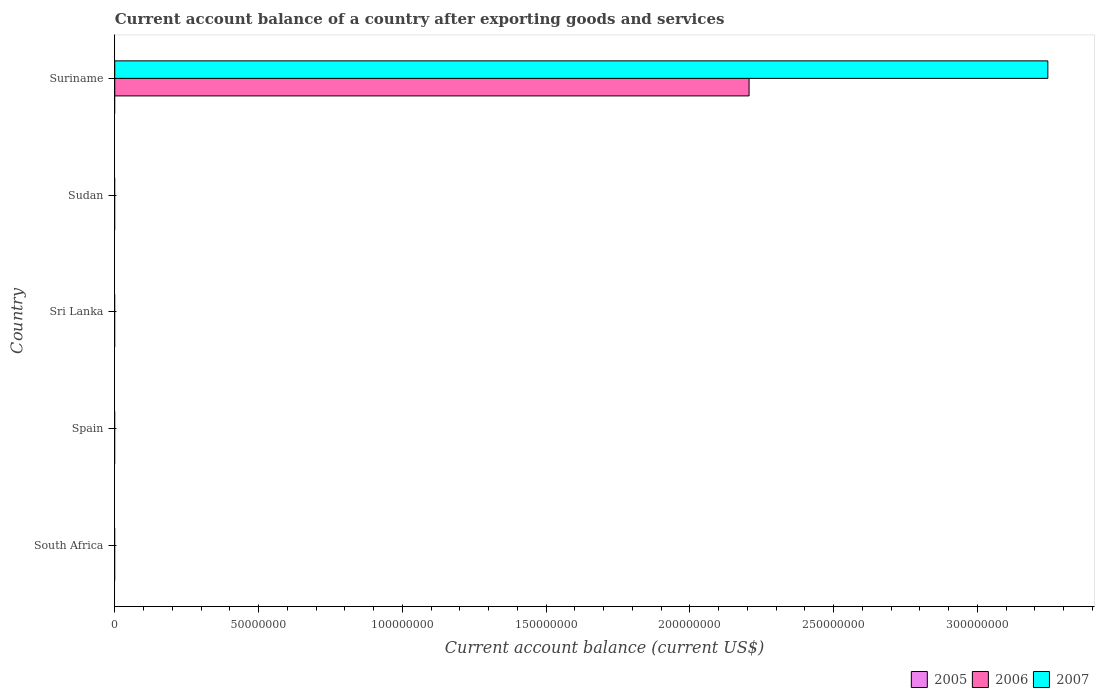How many bars are there on the 2nd tick from the top?
Make the answer very short. 0. What is the label of the 1st group of bars from the top?
Provide a succinct answer. Suriname. Across all countries, what is the maximum account balance in 2007?
Provide a short and direct response. 3.24e+08. In which country was the account balance in 2006 maximum?
Your answer should be very brief. Suriname. What is the total account balance in 2006 in the graph?
Provide a short and direct response. 2.21e+08. What is the difference between the account balance in 2005 in Spain and the account balance in 2006 in Suriname?
Give a very brief answer. -2.21e+08. What is the difference between the account balance in 2006 and account balance in 2007 in Suriname?
Your answer should be very brief. -1.04e+08. In how many countries, is the account balance in 2007 greater than 190000000 US$?
Ensure brevity in your answer.  1. What is the difference between the highest and the lowest account balance in 2006?
Your answer should be compact. 2.21e+08. In how many countries, is the account balance in 2006 greater than the average account balance in 2006 taken over all countries?
Your response must be concise. 1. Is it the case that in every country, the sum of the account balance in 2006 and account balance in 2007 is greater than the account balance in 2005?
Keep it short and to the point. No. Are all the bars in the graph horizontal?
Make the answer very short. Yes. How many countries are there in the graph?
Keep it short and to the point. 5. What is the difference between two consecutive major ticks on the X-axis?
Your answer should be compact. 5.00e+07. Are the values on the major ticks of X-axis written in scientific E-notation?
Your answer should be compact. No. Does the graph contain any zero values?
Make the answer very short. Yes. Where does the legend appear in the graph?
Make the answer very short. Bottom right. How many legend labels are there?
Offer a terse response. 3. What is the title of the graph?
Offer a terse response. Current account balance of a country after exporting goods and services. Does "2001" appear as one of the legend labels in the graph?
Your answer should be very brief. No. What is the label or title of the X-axis?
Provide a short and direct response. Current account balance (current US$). What is the Current account balance (current US$) in 2005 in South Africa?
Keep it short and to the point. 0. What is the Current account balance (current US$) of 2007 in Spain?
Provide a succinct answer. 0. What is the Current account balance (current US$) in 2005 in Sri Lanka?
Make the answer very short. 0. What is the Current account balance (current US$) of 2006 in Sri Lanka?
Provide a short and direct response. 0. What is the Current account balance (current US$) of 2007 in Sri Lanka?
Your answer should be very brief. 0. What is the Current account balance (current US$) of 2005 in Sudan?
Ensure brevity in your answer.  0. What is the Current account balance (current US$) in 2006 in Sudan?
Offer a terse response. 0. What is the Current account balance (current US$) in 2005 in Suriname?
Provide a succinct answer. 0. What is the Current account balance (current US$) in 2006 in Suriname?
Make the answer very short. 2.21e+08. What is the Current account balance (current US$) of 2007 in Suriname?
Provide a short and direct response. 3.24e+08. Across all countries, what is the maximum Current account balance (current US$) of 2006?
Your answer should be very brief. 2.21e+08. Across all countries, what is the maximum Current account balance (current US$) in 2007?
Give a very brief answer. 3.24e+08. Across all countries, what is the minimum Current account balance (current US$) in 2007?
Offer a very short reply. 0. What is the total Current account balance (current US$) in 2005 in the graph?
Ensure brevity in your answer.  0. What is the total Current account balance (current US$) of 2006 in the graph?
Make the answer very short. 2.21e+08. What is the total Current account balance (current US$) of 2007 in the graph?
Ensure brevity in your answer.  3.24e+08. What is the average Current account balance (current US$) in 2005 per country?
Offer a terse response. 0. What is the average Current account balance (current US$) in 2006 per country?
Give a very brief answer. 4.41e+07. What is the average Current account balance (current US$) of 2007 per country?
Provide a short and direct response. 6.49e+07. What is the difference between the Current account balance (current US$) of 2006 and Current account balance (current US$) of 2007 in Suriname?
Give a very brief answer. -1.04e+08. What is the difference between the highest and the lowest Current account balance (current US$) of 2006?
Provide a succinct answer. 2.21e+08. What is the difference between the highest and the lowest Current account balance (current US$) of 2007?
Provide a succinct answer. 3.24e+08. 